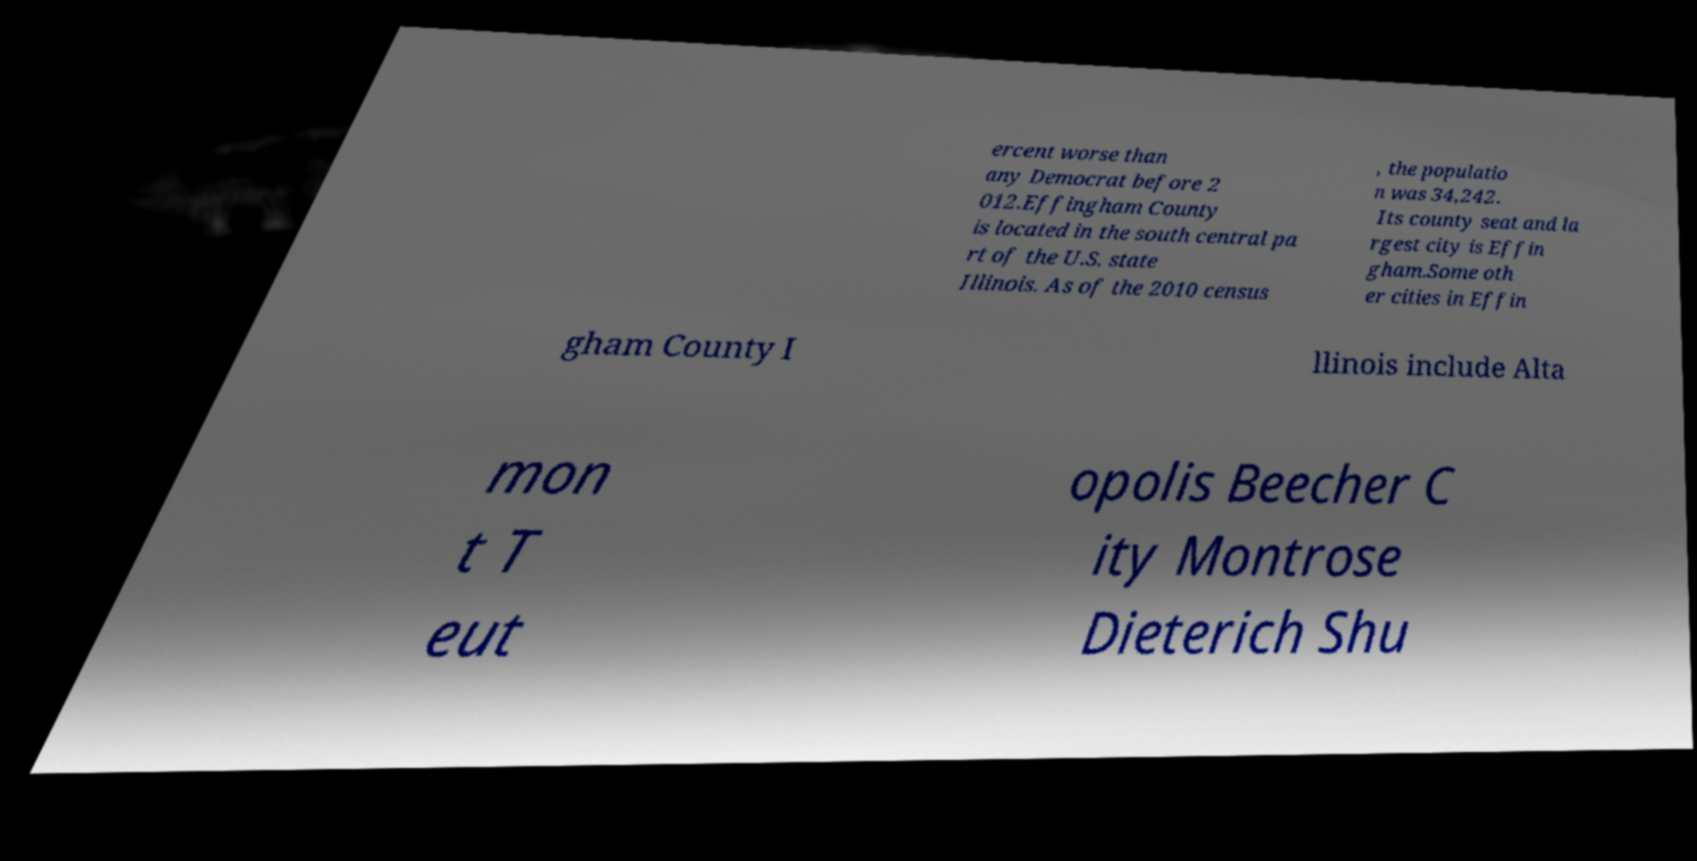Can you read and provide the text displayed in the image?This photo seems to have some interesting text. Can you extract and type it out for me? ercent worse than any Democrat before 2 012.Effingham County is located in the south central pa rt of the U.S. state Illinois. As of the 2010 census , the populatio n was 34,242. Its county seat and la rgest city is Effin gham.Some oth er cities in Effin gham County I llinois include Alta mon t T eut opolis Beecher C ity Montrose Dieterich Shu 